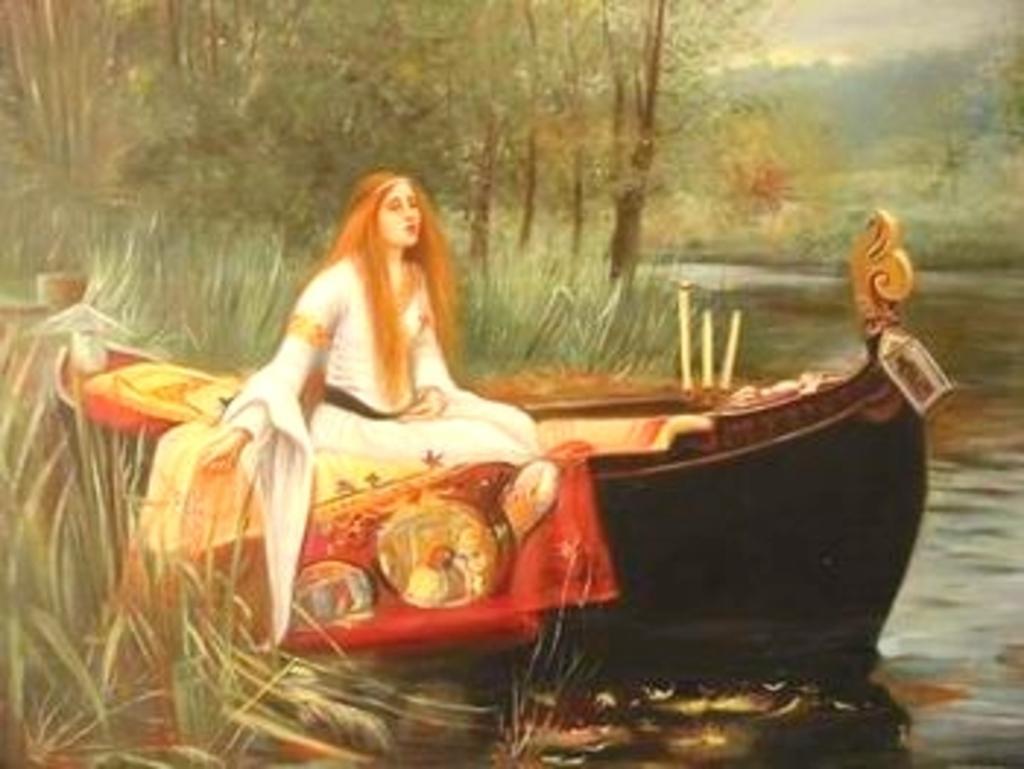How would you summarize this image in a sentence or two? This is an painting of a woman sitting on a boat wearing a white dress. There is water and trees. 